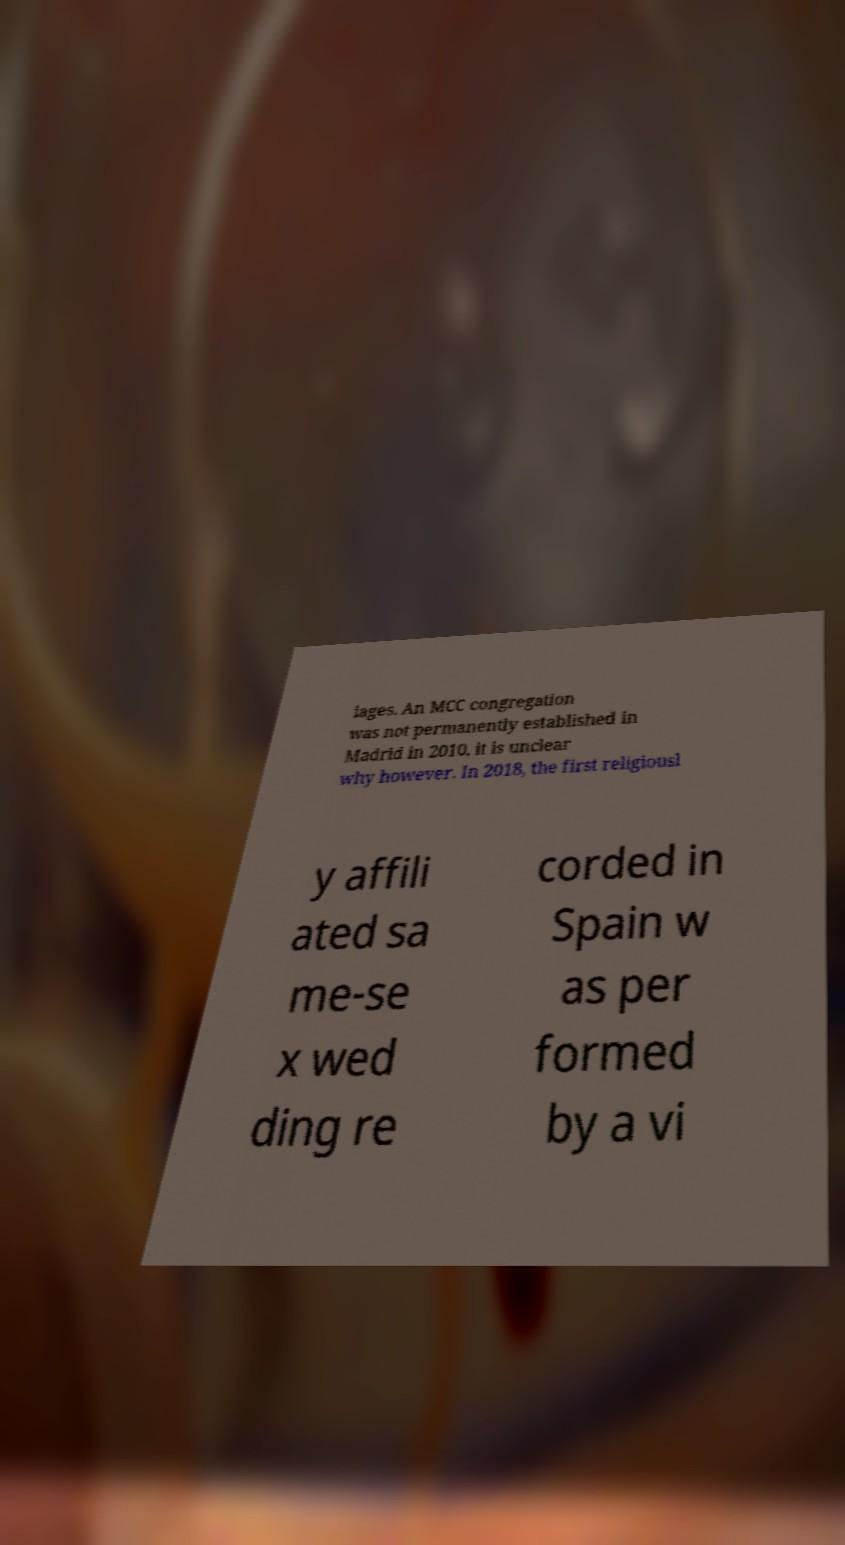What messages or text are displayed in this image? I need them in a readable, typed format. iages. An MCC congregation was not permanently established in Madrid in 2010, it is unclear why however. In 2018, the first religiousl y affili ated sa me-se x wed ding re corded in Spain w as per formed by a vi 